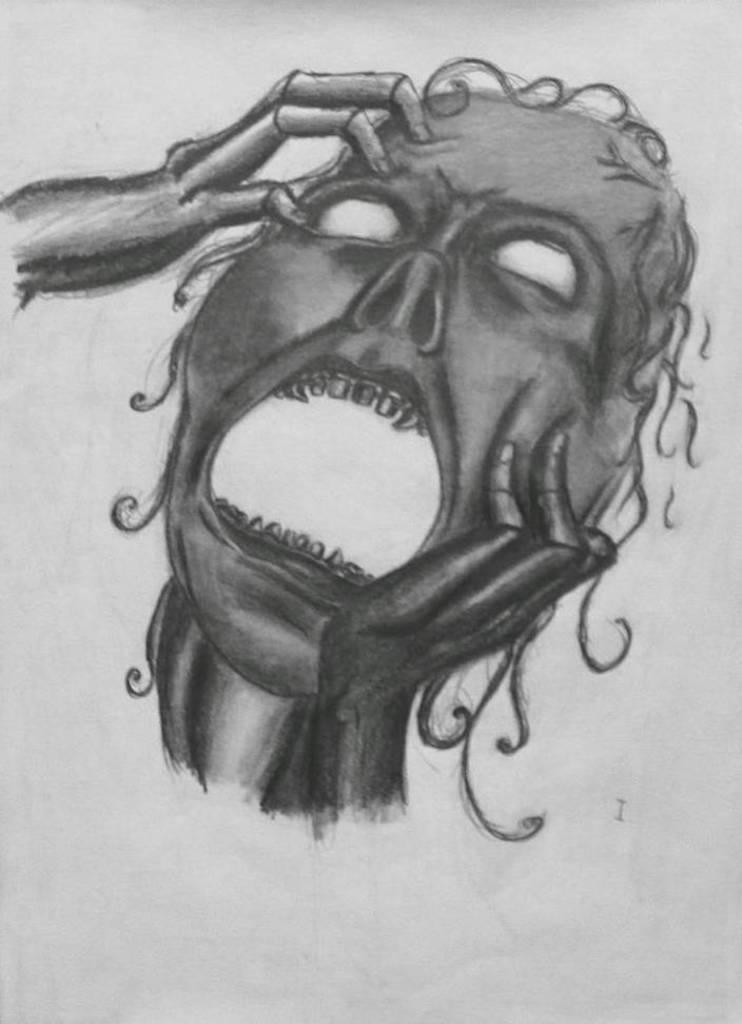What is the main subject of the image? The main subject of the image is a human. What is the human doing in the image? The human is drawing on a white surface. What type of wood is the throne made of in the image? There is no throne present in the image, so it is not possible to determine what type of wood it might be made of. 